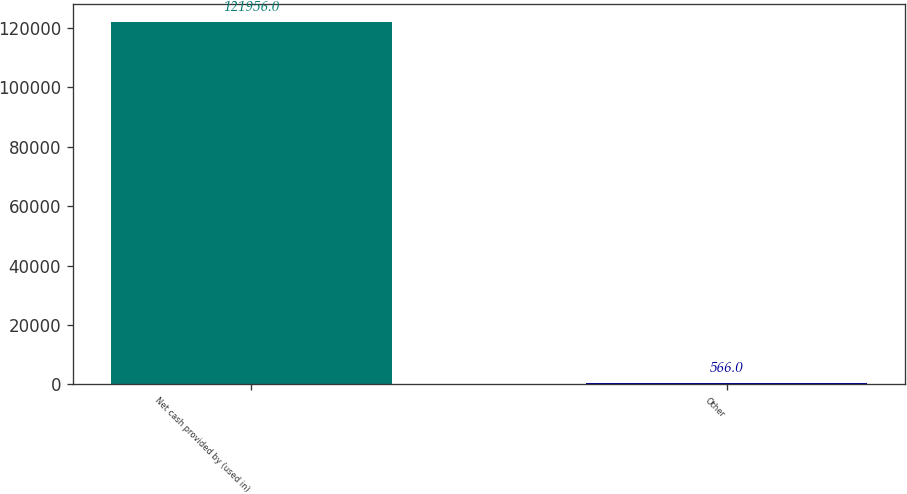Convert chart. <chart><loc_0><loc_0><loc_500><loc_500><bar_chart><fcel>Net cash provided by (used in)<fcel>Other<nl><fcel>121956<fcel>566<nl></chart> 